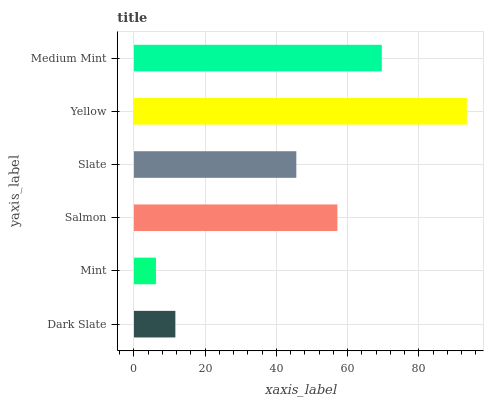Is Mint the minimum?
Answer yes or no. Yes. Is Yellow the maximum?
Answer yes or no. Yes. Is Salmon the minimum?
Answer yes or no. No. Is Salmon the maximum?
Answer yes or no. No. Is Salmon greater than Mint?
Answer yes or no. Yes. Is Mint less than Salmon?
Answer yes or no. Yes. Is Mint greater than Salmon?
Answer yes or no. No. Is Salmon less than Mint?
Answer yes or no. No. Is Salmon the high median?
Answer yes or no. Yes. Is Slate the low median?
Answer yes or no. Yes. Is Medium Mint the high median?
Answer yes or no. No. Is Dark Slate the low median?
Answer yes or no. No. 